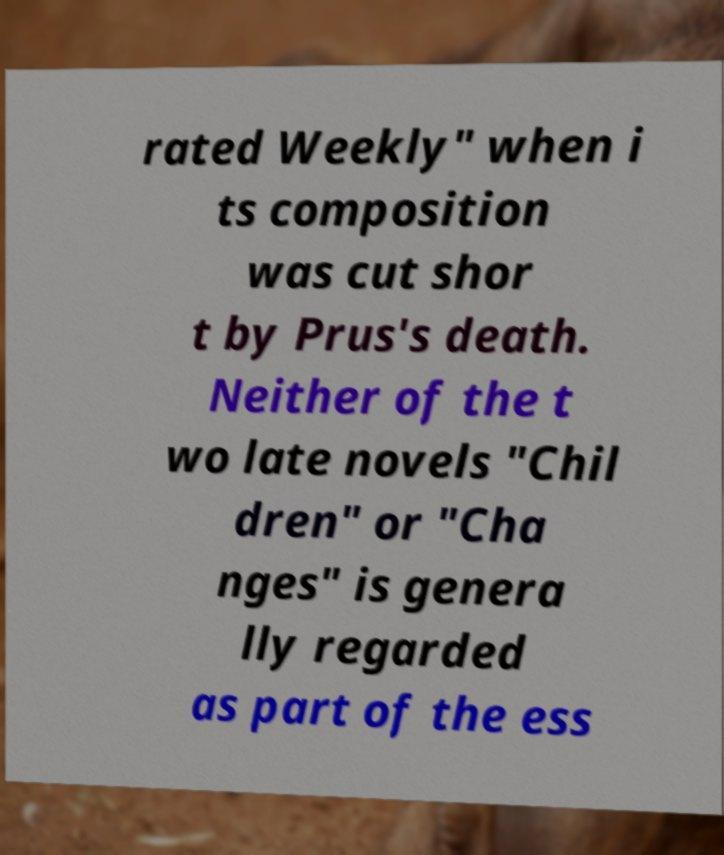I need the written content from this picture converted into text. Can you do that? rated Weekly" when i ts composition was cut shor t by Prus's death. Neither of the t wo late novels "Chil dren" or "Cha nges" is genera lly regarded as part of the ess 